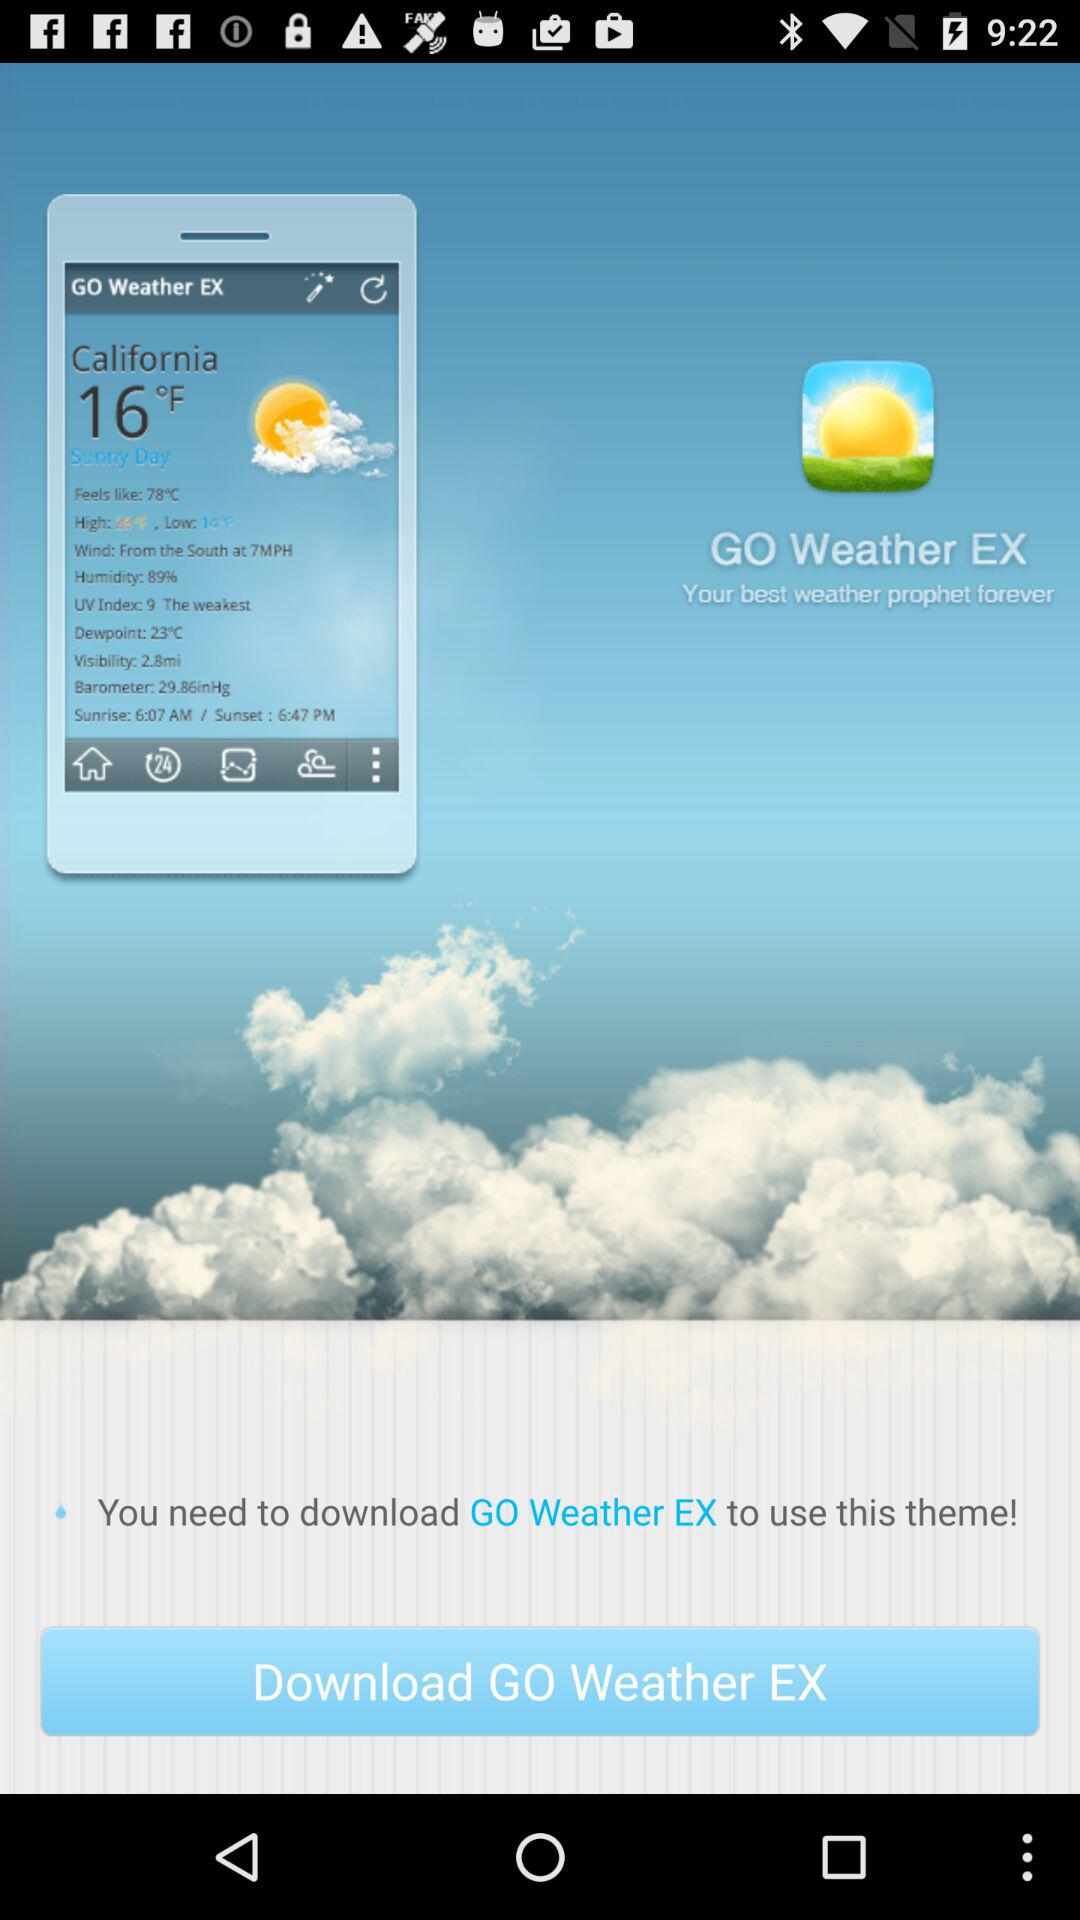What is the sunset time in California? The sunset time in California is 6:47 PM. 